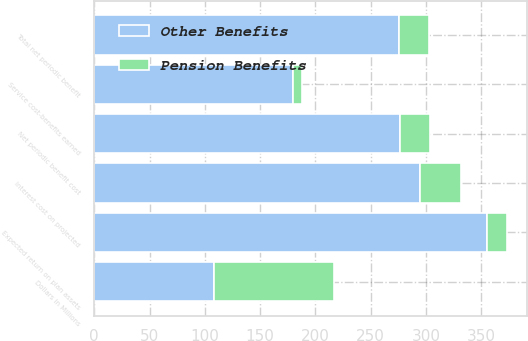<chart> <loc_0><loc_0><loc_500><loc_500><stacked_bar_chart><ecel><fcel>Dollars in Millions<fcel>Service cost-benefits earned<fcel>Interest cost on projected<fcel>Expected return on plan assets<fcel>Net periodic benefit cost<fcel>Total net periodic benefit<nl><fcel>Other Benefits<fcel>108.5<fcel>180<fcel>295<fcel>355<fcel>277<fcel>276<nl><fcel>Pension Benefits<fcel>108.5<fcel>8<fcel>37<fcel>18<fcel>27<fcel>27<nl></chart> 